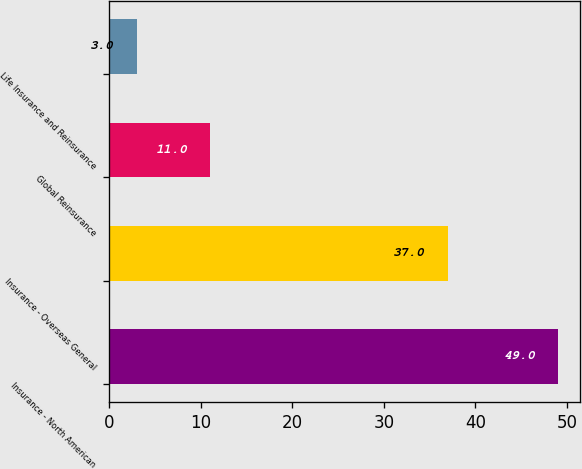Convert chart to OTSL. <chart><loc_0><loc_0><loc_500><loc_500><bar_chart><fcel>Insurance - North American<fcel>Insurance - Overseas General<fcel>Global Reinsurance<fcel>Life Insurance and Reinsurance<nl><fcel>49<fcel>37<fcel>11<fcel>3<nl></chart> 